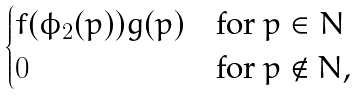<formula> <loc_0><loc_0><loc_500><loc_500>\begin{cases} f ( \phi _ { 2 } ( p ) ) g ( p ) & \text {for $p\in N$} \\ 0 & \text {for $p\notin N$,} \end{cases}</formula> 